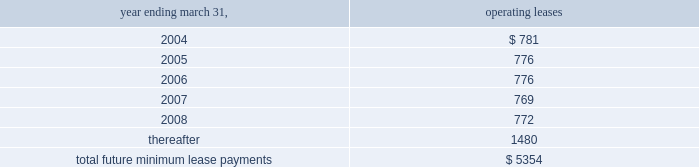A lump sum buyout cost of approximately $ 1.1 million .
Total rent expense under these leases , included in the accompanying consolidated statements of operations , was approximately $ 893000 , $ 856000 and $ 823000 for the fiscal years ended march 31 , 2001 , 2002 and 2003 , respectively .
During the fiscal year ended march 31 , 2000 , the company entered into 36-month operating leases totaling approximately $ 644000 for the lease of office furniture .
These leases ended in fiscal year 2003 and at the company 2019s option the furniture was purchased at its fair market value .
Rental expense recorded for these leases during the fiscal years ended march 31 , 2001 , 2002 and 2003 was approximately $ 215000 , $ 215000 and $ 127000 respectively .
During fiscal 2000 , the company entered into a 36-month capital lease for computer equipment and software for approximately $ 221000 .
This lease ended in fiscal year 2003 and at the company 2019s option these assets were purchased at the stipulated buyout price .
Future minimum lease payments under all non-cancelable operating leases as of march 31 , 2003 are approximately as follows ( in thousands ) : .
From time to time , the company is involved in legal and administrative proceedings and claims of various types .
While any litigation contains an element of uncertainty , management , in consultation with the company 2019s general counsel , presently believes that the outcome of each such other proceedings or claims which are pending or known to be threatened , or all of them combined , will not have a material adverse effect on the company .
Stock option and purchase plans all stock options granted by the company under the below-described plans were granted at the fair value of the underlying common stock at the date of grant .
Outstanding stock options , if not exercised , expire 10 years from the date of grant .
The 1992 combination stock option plan ( the combination plan ) , as amended , was adopted in september 1992 as a combination and restatement of the company 2019s then outstanding incentive stock option plan and nonqualified plan .
A total of 2670859 options were awarded from the combination plan during its ten-year restatement term that ended on may 1 , 2002 .
As of march 31 , 2003 , 1286042 of these options remain outstanding and eligible for future exercise .
These options are held by company employees and generally become exercisable ratably over five years .
The 1998 equity incentive plan , ( the equity incentive plan ) , was adopted by the company in august 1998 .
The equity incentive plan provides for grants of options to key employees , directors , advisors and consultants as either incentive stock options or nonqualified stock options as determined by the company 2019s board of directors .
A maximum of 1000000 shares of common stock may be awarded under this plan .
Options granted under the equity incentive plan are exercisable at such times and subject to such terms as the board of directors may specify at the time of each stock option grant .
Options outstanding under the equity incentive plan have vesting periods of 3 to 5 years from the date of grant .
The 2000 stock incentive plan , ( the 2000 plan ) , was adopted by the company in august 2000 .
The 2000 plan provides for grants of options to key employees , directors , advisors and consultants to the company or its subsidiaries as either incentive or nonqualified stock options as determined by the company 2019s board of directors .
Up to 1400000 shares of common stock may be awarded under the 2000 plan and are exercisable at such times and subject to such terms as the board of directors may specify at the time of each stock option grant .
Options outstanding under the 2000 plan generally vested 4 years from the date of grant .
The company has a nonqualified stock option plan for non-employee directors ( the directors 2019 plan ) .
The directors 2019 plan , as amended , was adopted in july 1989 and provides for grants of options to purchase shares of the company 2019s common stock to non-employee directors of the company .
Up to 400000 shares of common stock may be awarded under the directors 2019 plan .
Options outstanding under the directors 2019 plan have vesting periods of 1 to 5 years from the date of grant .
Notes to consolidated financial statements ( continued ) march 31 , 2003 page 25 .
What portion of total future minimum lease payments is due in the next 12 months? 
Computations: (781 / 5354)
Answer: 0.14587. 